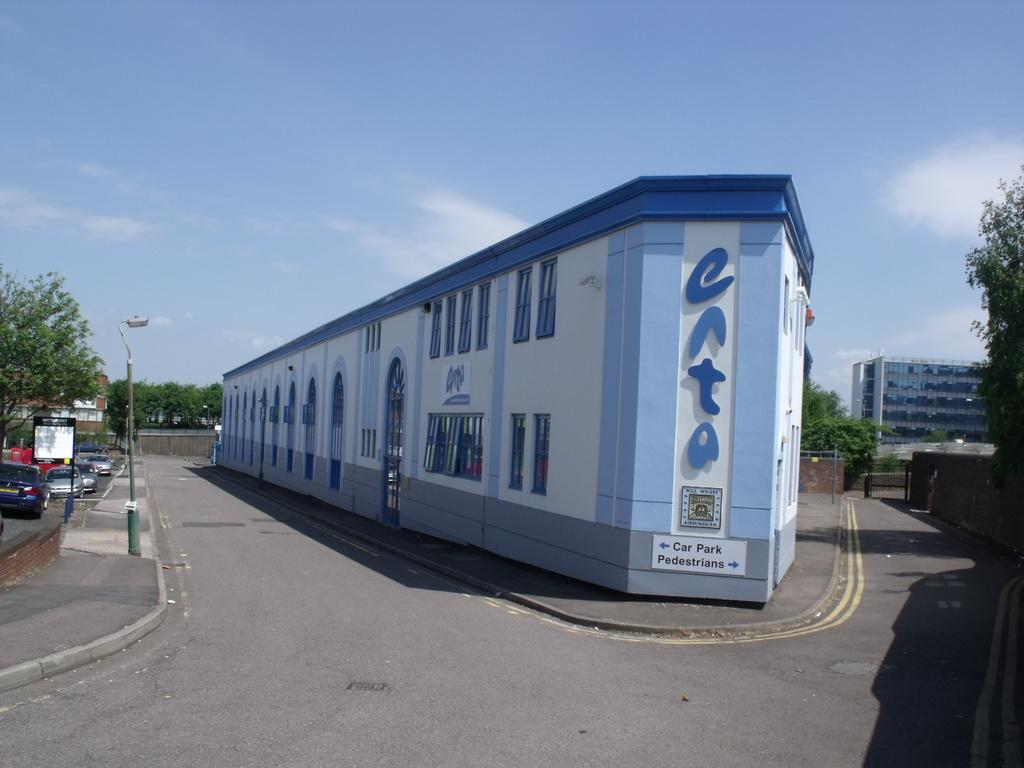<image>
Present a compact description of the photo's key features. A blue and white building with a sign on it directing car and pedestrian traffic 